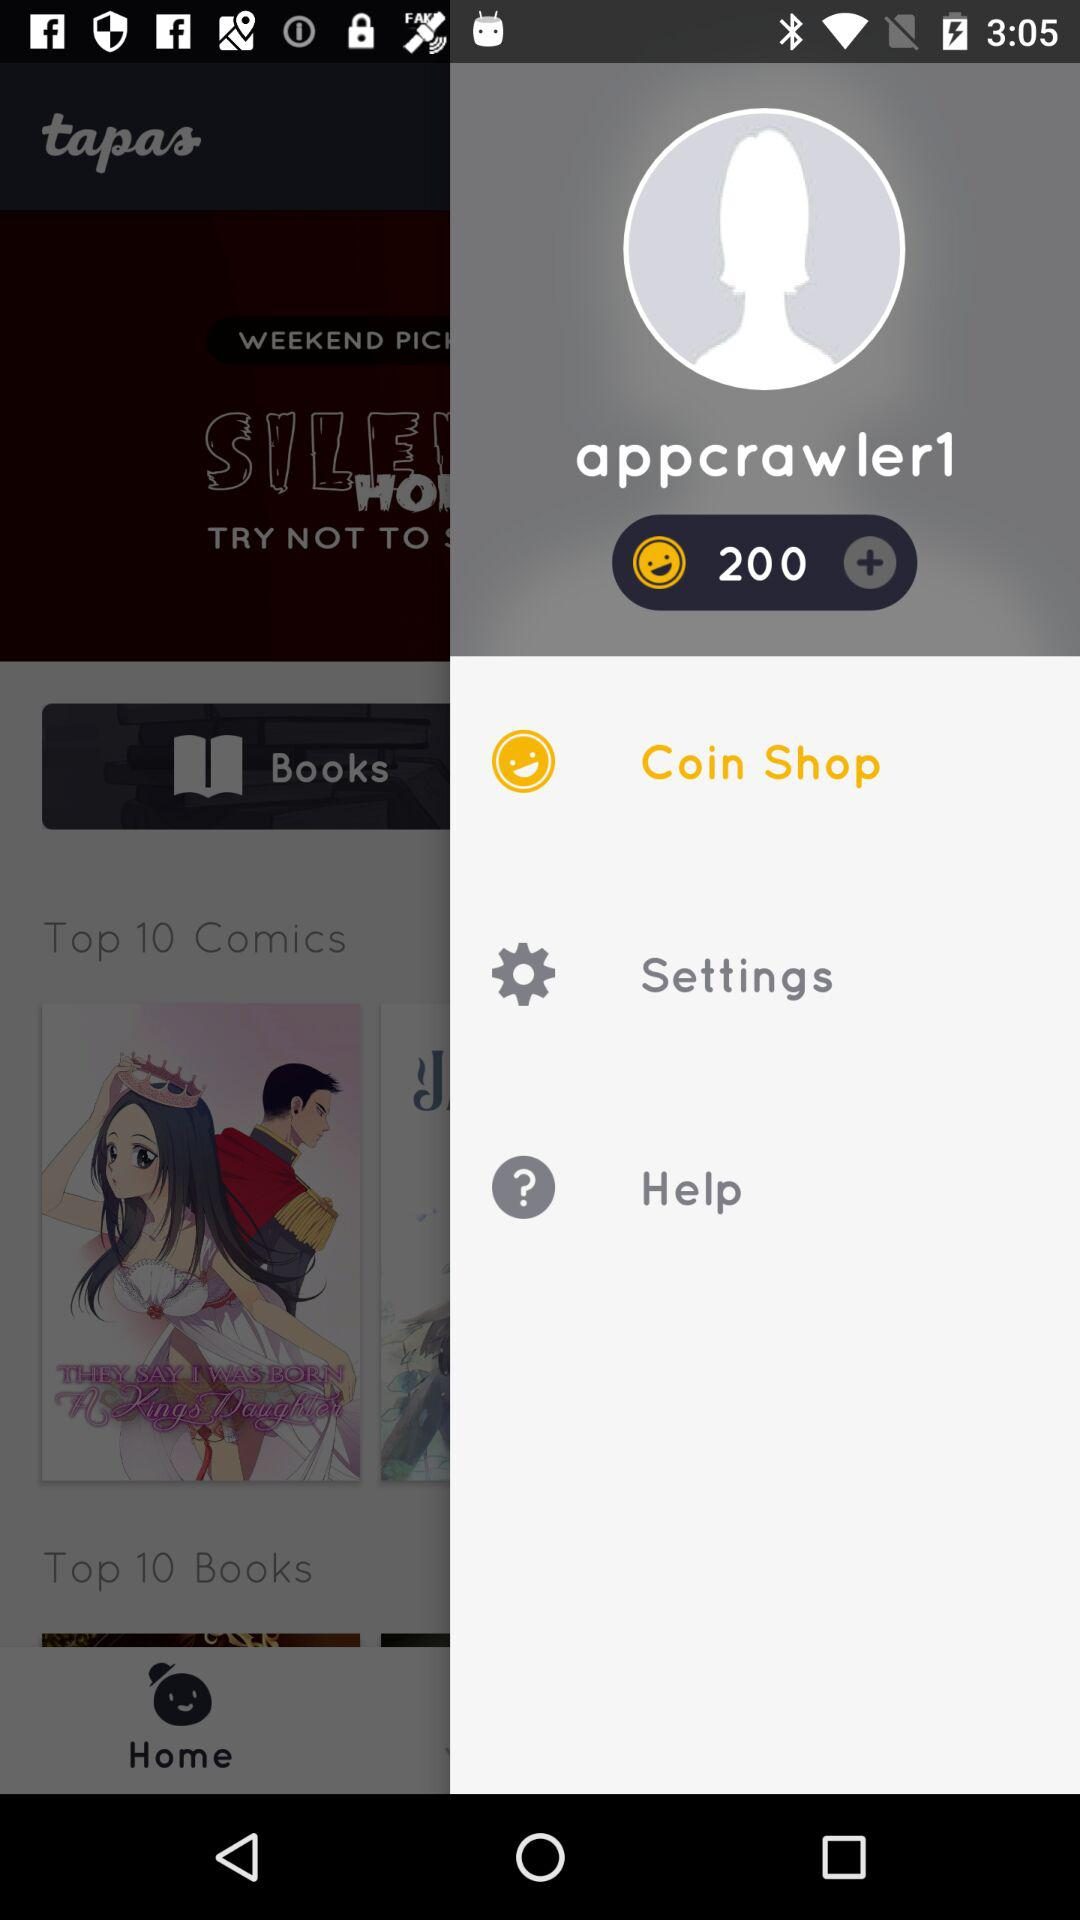Which item is selected? The selected item is "Coin Shop". 